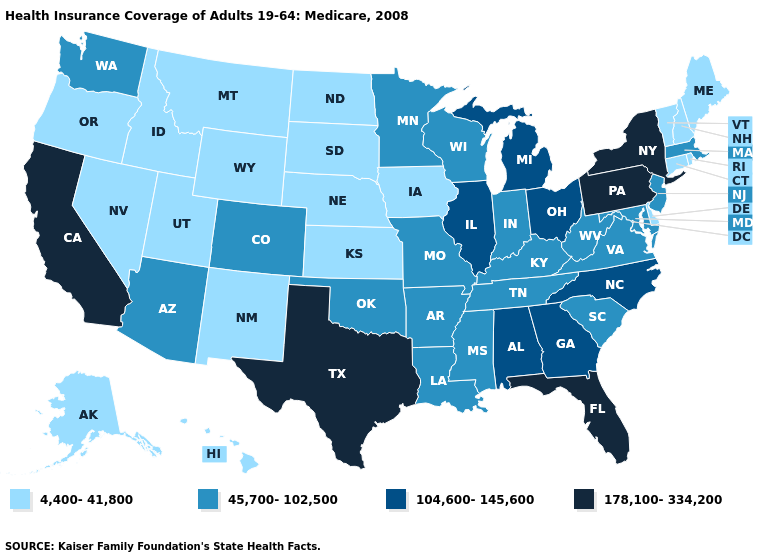Name the states that have a value in the range 178,100-334,200?
Write a very short answer. California, Florida, New York, Pennsylvania, Texas. What is the lowest value in the USA?
Give a very brief answer. 4,400-41,800. What is the value of Massachusetts?
Be succinct. 45,700-102,500. How many symbols are there in the legend?
Give a very brief answer. 4. What is the value of Georgia?
Short answer required. 104,600-145,600. Does Delaware have a lower value than Wyoming?
Concise answer only. No. Name the states that have a value in the range 45,700-102,500?
Write a very short answer. Arizona, Arkansas, Colorado, Indiana, Kentucky, Louisiana, Maryland, Massachusetts, Minnesota, Mississippi, Missouri, New Jersey, Oklahoma, South Carolina, Tennessee, Virginia, Washington, West Virginia, Wisconsin. Which states hav the highest value in the Northeast?
Write a very short answer. New York, Pennsylvania. What is the value of Minnesota?
Answer briefly. 45,700-102,500. Name the states that have a value in the range 104,600-145,600?
Concise answer only. Alabama, Georgia, Illinois, Michigan, North Carolina, Ohio. How many symbols are there in the legend?
Write a very short answer. 4. What is the value of New Mexico?
Answer briefly. 4,400-41,800. Name the states that have a value in the range 45,700-102,500?
Quick response, please. Arizona, Arkansas, Colorado, Indiana, Kentucky, Louisiana, Maryland, Massachusetts, Minnesota, Mississippi, Missouri, New Jersey, Oklahoma, South Carolina, Tennessee, Virginia, Washington, West Virginia, Wisconsin. Which states have the lowest value in the USA?
Give a very brief answer. Alaska, Connecticut, Delaware, Hawaii, Idaho, Iowa, Kansas, Maine, Montana, Nebraska, Nevada, New Hampshire, New Mexico, North Dakota, Oregon, Rhode Island, South Dakota, Utah, Vermont, Wyoming. 